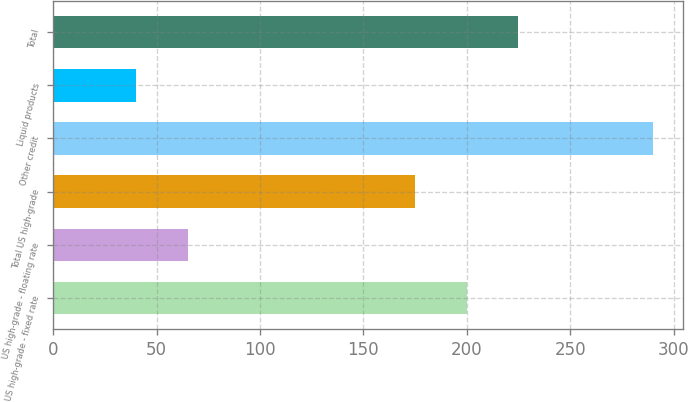Convert chart. <chart><loc_0><loc_0><loc_500><loc_500><bar_chart><fcel>US high-grade - fixed rate<fcel>US high-grade - floating rate<fcel>Total US high-grade<fcel>Other credit<fcel>Liquid products<fcel>Total<nl><fcel>200<fcel>65<fcel>175<fcel>290<fcel>40<fcel>225<nl></chart> 